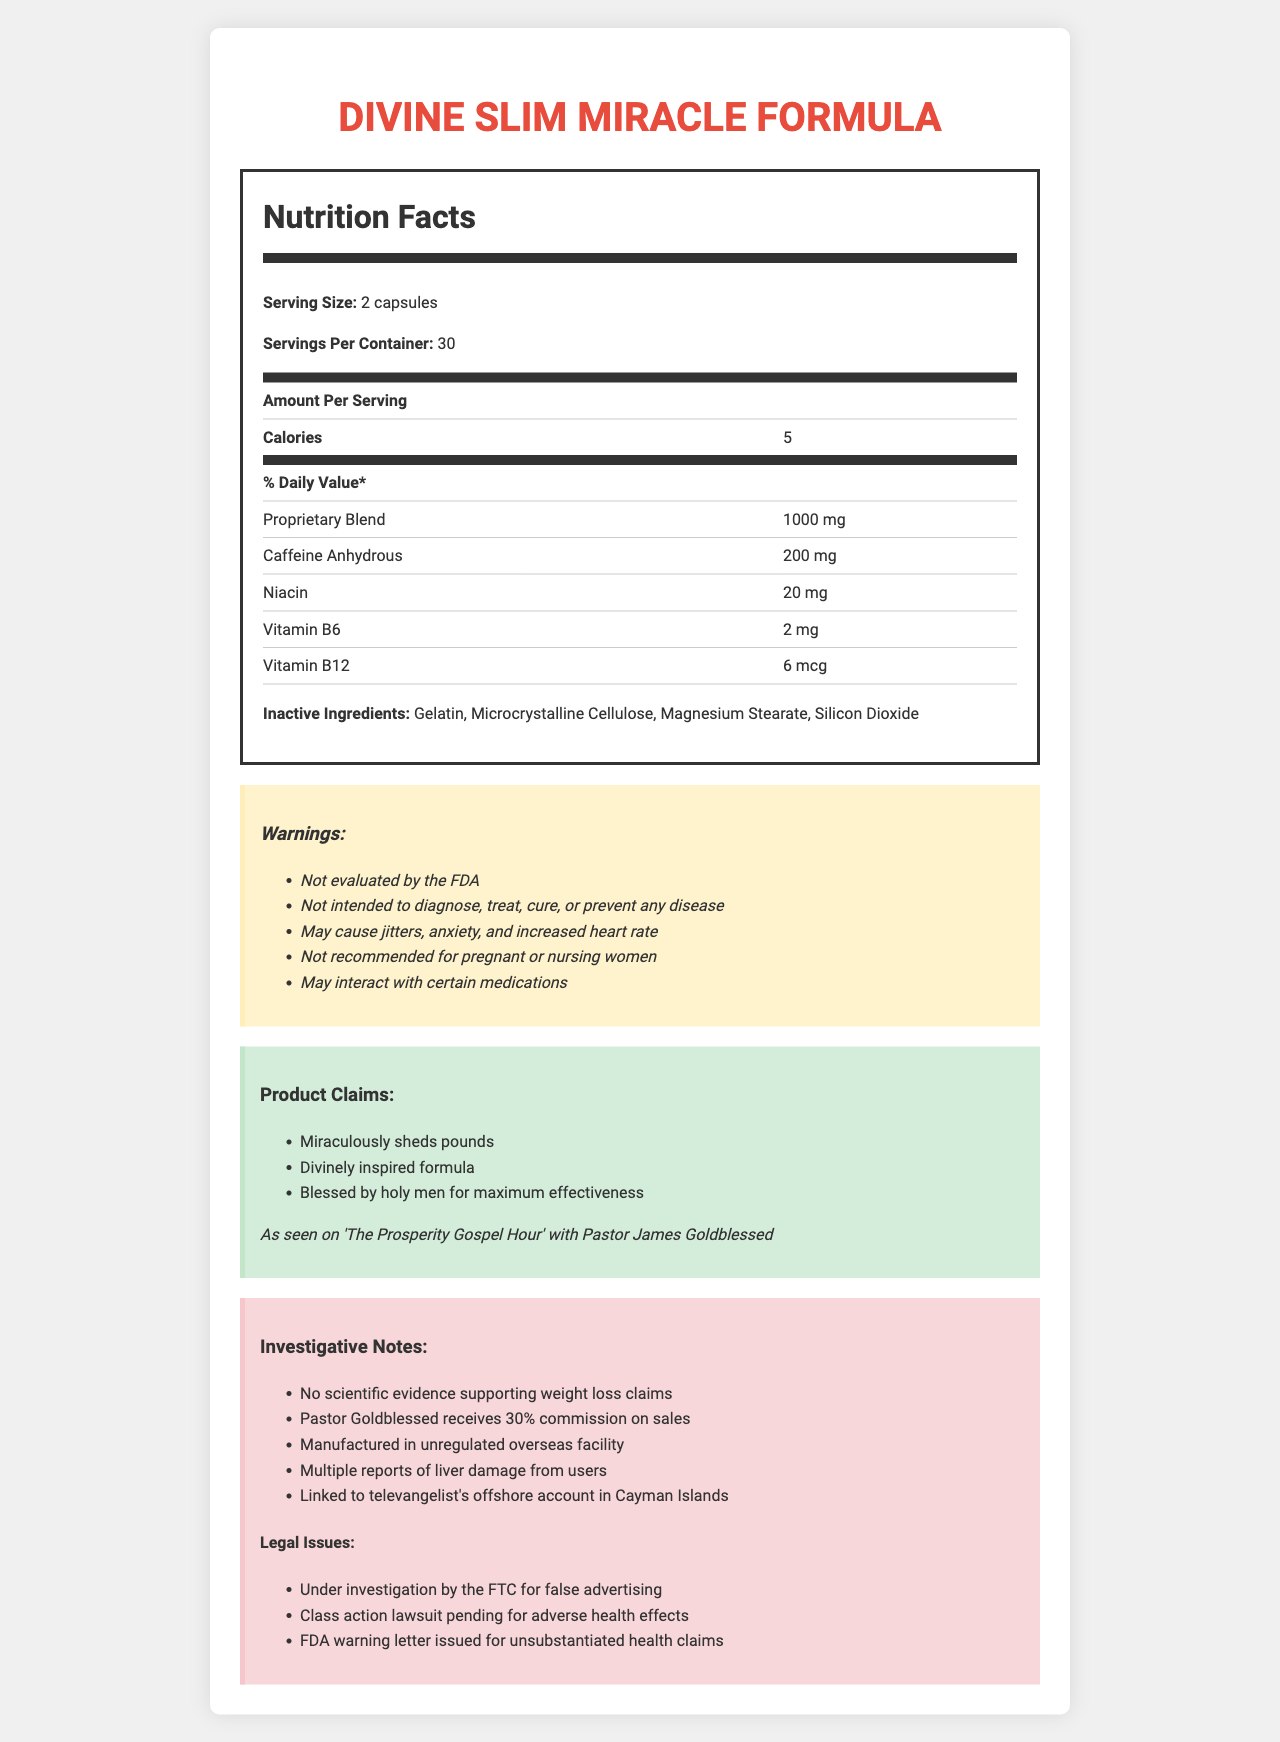how many calories are in one serving of Divine Slim Miracle Formula? The document explicitly states that each serving of the Divine Slim Miracle Formula contains 5 calories, as seen under the nutrition facts section.
Answer: 5 what is the serving size for the Divine Slim Miracle Formula? The serving size is mentioned in the nutrition facts section of the document as "2 capsules."
Answer: 2 capsules name three active ingredients in the Proprietary Blend. These ingredients are listed under the Proprietary Blend in the ingredient section of the document.
Answer: Green Tea Extract, Garcinia Cambogia, Acai Berry Powder what are the warnings associated with using this product? The section labeled "Warnings" contains a complete list of these warnings.
Answer: Not evaluated by the FDA, Not intended to diagnose, treat, cure, or prevent any disease, May cause jitters, anxiety, and increased heart rate, Not recommended for pregnant or nursing women, May interact with certain medications what endorsements does the Divine Slim Miracle Formula have? This endorsement is listed in the claims section of the document.
Answer: As seen on 'The Prosperity Gospel Hour' with Pastor James Goldblessed what percentage of commission does Pastor Goldblessed receive on sales? The investigative notes indicate that Pastor Goldblessed receives a 30% commission on sales.
Answer: 30% what are some potential health risks mentioned in the investigative notes? These risks are mentioned in both the warnings and investigative notes sections of the document.
Answer: Liver damage, Jitters, Anxiety, Increased heart rate what is the amount of Niacin in one serving of the supplement? A. 10 mg B. 20 mg C. 30 mg D. 5 mg The ingredient section lists Niacin as containing 20 mg per serving.
Answer: B. 20 mg which legal issue is NOT associated with Divine Slim Miracle Formula? A. Under investigation by the FTC for false advertising B. Class action lawsuit pending for adverse health effects C. FDA warning letter issued for unsubstantiated health claims D. Patent infringement lawsuit The legal issues listed do not mention a patent infringement lawsuit.
Answer: D is the product intended to diagnose, treat, cure, or prevent any disease? (yes/no) According to the warnings section, the product is not intended to diagnose, treat, cure, or prevent any disease.
Answer: No summarize the main issue with the Divine Slim Miracle Formula. The document details various ineffective ingredients, potential health risks, lack of scientific evidence, and financial and legal controversies surrounding the product.
Answer: The Divine Slim Miracle Formula is a weight loss supplement endorsed by televangelist Pastor James Goldblessed, containing ingredients with no scientific support for its claims. It poses health risks, is under legal scrutiny, and is marketed with deceptive practices. who manufactures the Divine Slim Miracle Formula? The document does not provide information on the manufacturer of the Divine Slim Miracle Formula.
Answer: Cannot be determined 